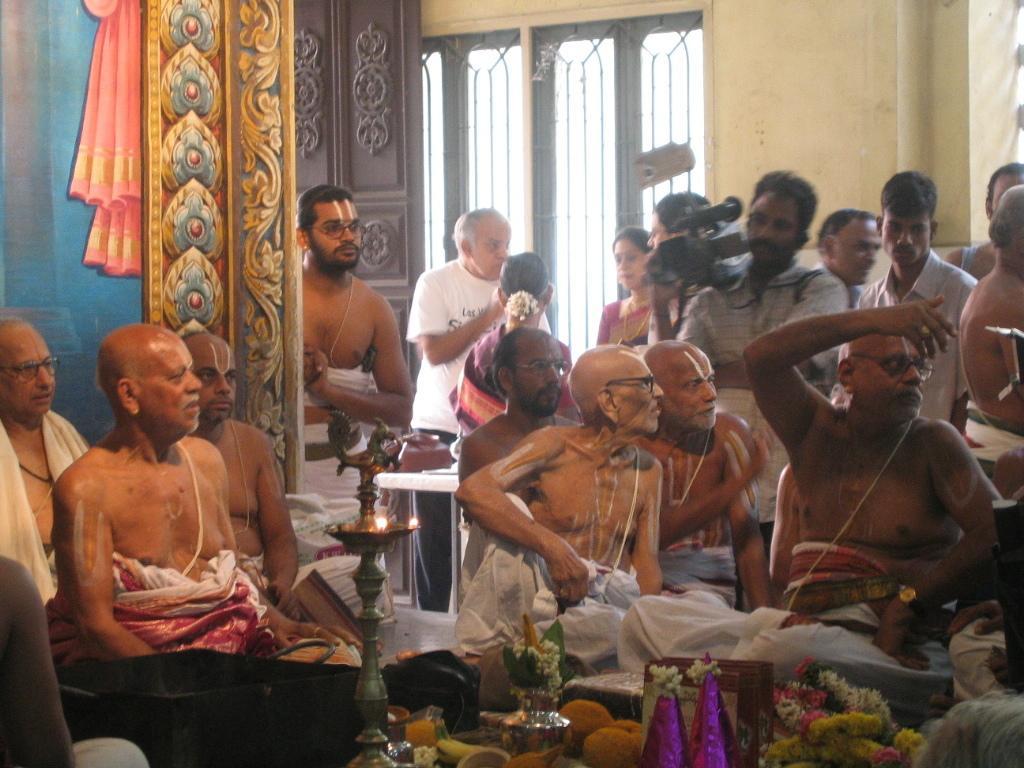Describe this image in one or two sentences. This picture shows few people seated and few are standing and we see a man Standing and holding a video camera in his hand. 